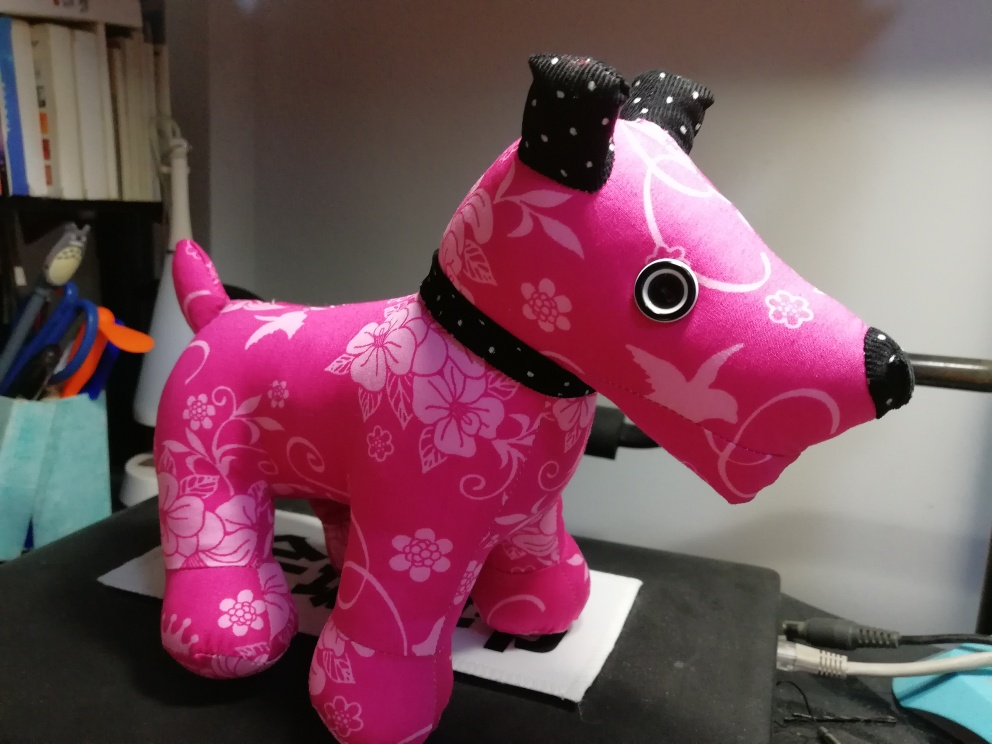Is this object intended for practical use or decorative purposes? Based on the image, this object appears to be designed for decorative purposes. Its vibrant design, along with the lack of moving parts, suggests it's meant to be an ornamental piece rather than a functional item. 